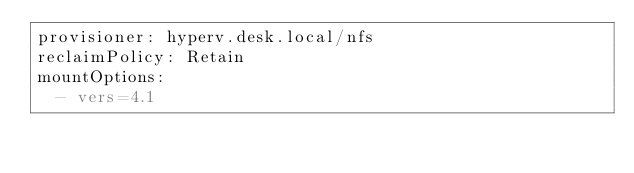Convert code to text. <code><loc_0><loc_0><loc_500><loc_500><_YAML_>provisioner: hyperv.desk.local/nfs
reclaimPolicy: Retain
mountOptions:
  - vers=4.1
</code> 